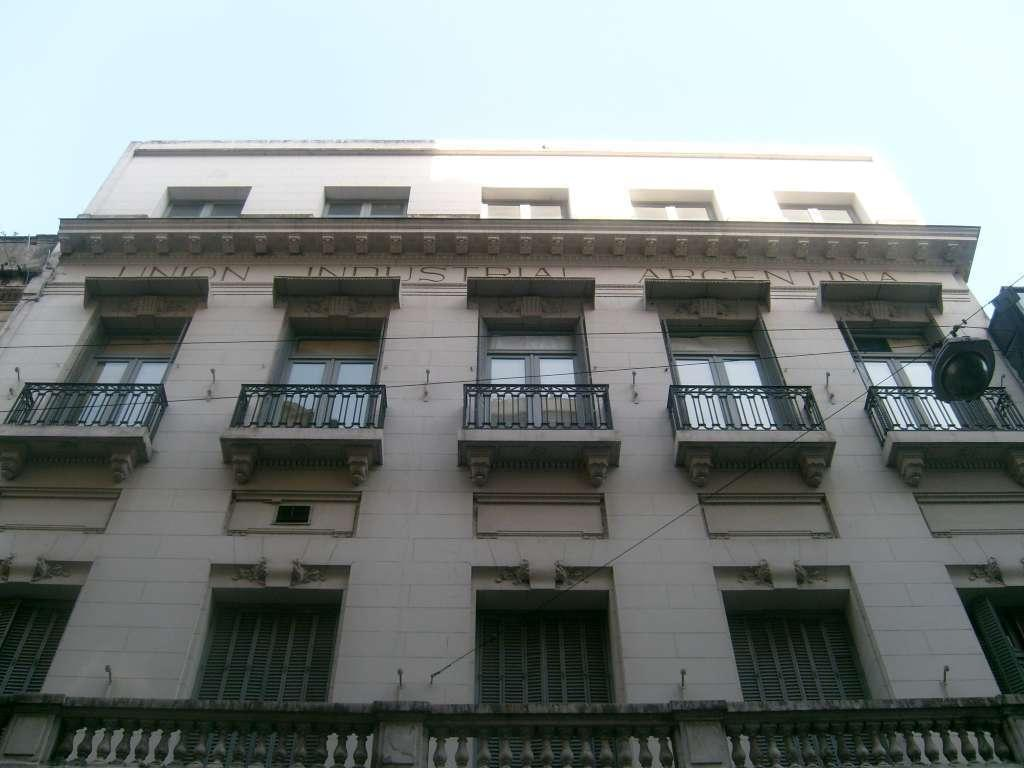What is the main structure in the foreground of the image? There is a building in the foreground of the image. What object can be seen attached to a cable in the foreground? There is a lamp-like object attached to a cable in the foreground. What feature is present on the building? Railings are visible in the image. What can be seen on the building that allows light to enter? Windows are present on the building. What is visible at the top of the image? The sky is visible at the top of the image. What type of motion can be seen in the image? There is no motion visible in the image; it is a still photograph. What is the source of surprise in the image? There is no source of surprise in the image; it is a straightforward depiction of a building, lamp-like object, railings, windows, and sky. 